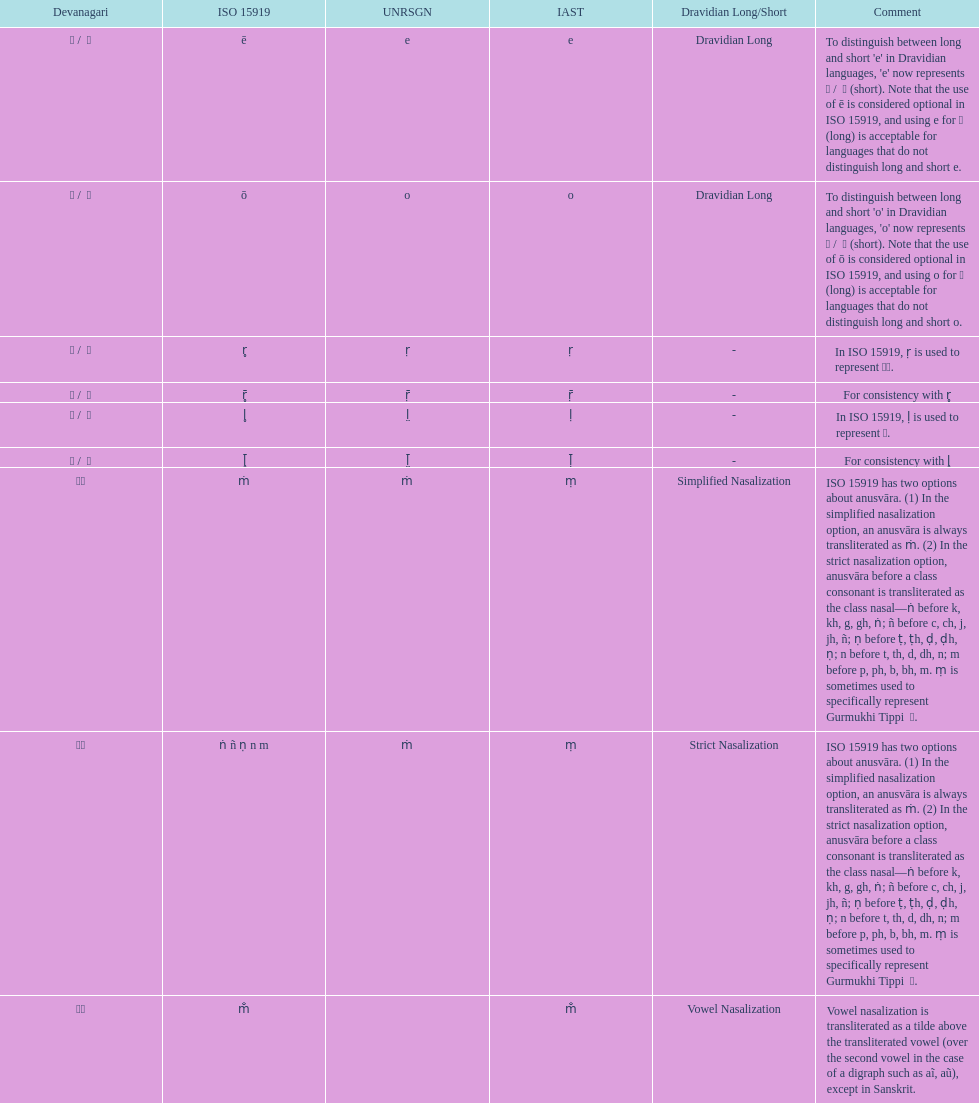This table shows the difference between how many transliterations? 3. 